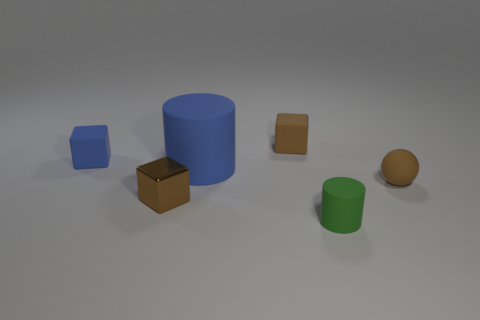Is the number of brown metallic objects behind the tiny sphere greater than the number of gray things? Upon reviewing the scene, there appears to be a single brown metallic cube, and no gray objects are visible, making the number of brown metallic objects behind the tiny brown sphere greater than the number of gray things, as there are none. 